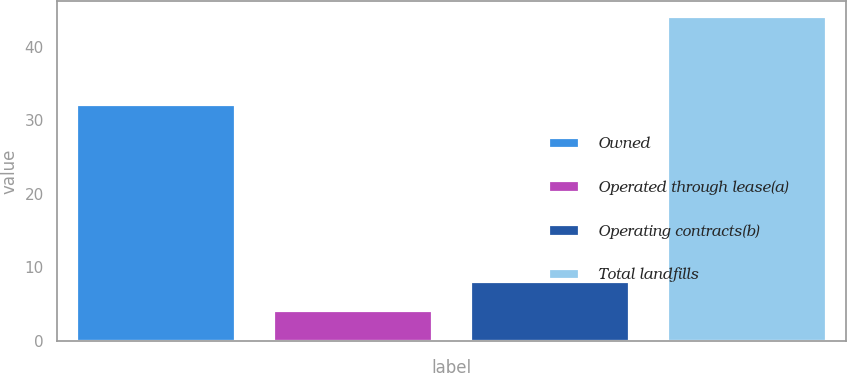Convert chart to OTSL. <chart><loc_0><loc_0><loc_500><loc_500><bar_chart><fcel>Owned<fcel>Operated through lease(a)<fcel>Operating contracts(b)<fcel>Total landfills<nl><fcel>32<fcel>4<fcel>8<fcel>44<nl></chart> 